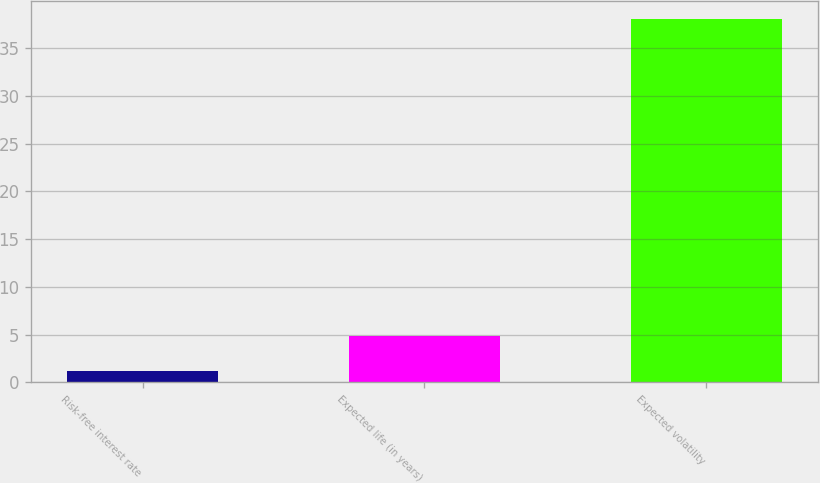<chart> <loc_0><loc_0><loc_500><loc_500><bar_chart><fcel>Risk-free interest rate<fcel>Expected life (in years)<fcel>Expected volatility<nl><fcel>1.2<fcel>4.88<fcel>38<nl></chart> 